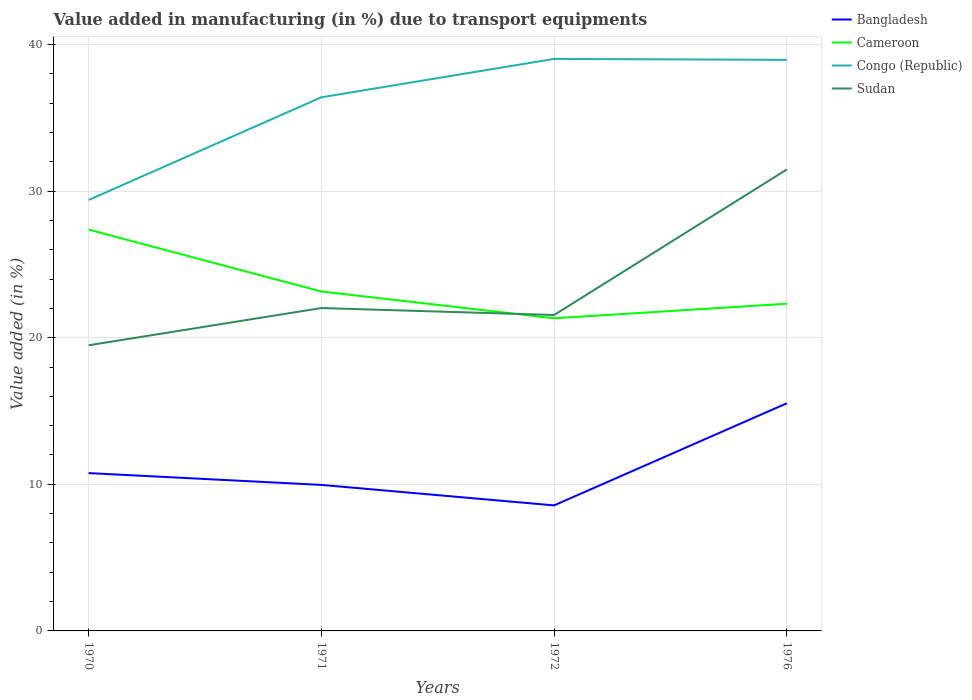How many different coloured lines are there?
Your answer should be compact. 4. Does the line corresponding to Sudan intersect with the line corresponding to Congo (Republic)?
Your answer should be very brief. No. Is the number of lines equal to the number of legend labels?
Offer a terse response. Yes. Across all years, what is the maximum percentage of value added in manufacturing due to transport equipments in Congo (Republic)?
Your answer should be very brief. 29.39. What is the total percentage of value added in manufacturing due to transport equipments in Bangladesh in the graph?
Provide a short and direct response. -6.97. What is the difference between the highest and the second highest percentage of value added in manufacturing due to transport equipments in Sudan?
Your answer should be compact. 11.99. What is the difference between the highest and the lowest percentage of value added in manufacturing due to transport equipments in Sudan?
Make the answer very short. 1. How many lines are there?
Offer a very short reply. 4. Are the values on the major ticks of Y-axis written in scientific E-notation?
Offer a very short reply. No. Does the graph contain grids?
Ensure brevity in your answer.  Yes. How many legend labels are there?
Keep it short and to the point. 4. How are the legend labels stacked?
Provide a succinct answer. Vertical. What is the title of the graph?
Keep it short and to the point. Value added in manufacturing (in %) due to transport equipments. What is the label or title of the X-axis?
Provide a short and direct response. Years. What is the label or title of the Y-axis?
Make the answer very short. Value added (in %). What is the Value added (in %) in Bangladesh in 1970?
Provide a succinct answer. 10.77. What is the Value added (in %) in Cameroon in 1970?
Your response must be concise. 27.37. What is the Value added (in %) in Congo (Republic) in 1970?
Provide a short and direct response. 29.39. What is the Value added (in %) in Sudan in 1970?
Your answer should be very brief. 19.48. What is the Value added (in %) in Bangladesh in 1971?
Provide a short and direct response. 9.96. What is the Value added (in %) in Cameroon in 1971?
Offer a terse response. 23.15. What is the Value added (in %) in Congo (Republic) in 1971?
Offer a very short reply. 36.4. What is the Value added (in %) in Sudan in 1971?
Your answer should be compact. 22.02. What is the Value added (in %) in Bangladesh in 1972?
Your answer should be very brief. 8.56. What is the Value added (in %) in Cameroon in 1972?
Provide a succinct answer. 21.32. What is the Value added (in %) in Congo (Republic) in 1972?
Provide a short and direct response. 39.02. What is the Value added (in %) of Sudan in 1972?
Offer a terse response. 21.55. What is the Value added (in %) in Bangladesh in 1976?
Provide a short and direct response. 15.53. What is the Value added (in %) of Cameroon in 1976?
Your answer should be compact. 22.32. What is the Value added (in %) of Congo (Republic) in 1976?
Ensure brevity in your answer.  38.95. What is the Value added (in %) of Sudan in 1976?
Your answer should be very brief. 31.48. Across all years, what is the maximum Value added (in %) in Bangladesh?
Your answer should be very brief. 15.53. Across all years, what is the maximum Value added (in %) in Cameroon?
Your answer should be compact. 27.37. Across all years, what is the maximum Value added (in %) of Congo (Republic)?
Your answer should be compact. 39.02. Across all years, what is the maximum Value added (in %) of Sudan?
Keep it short and to the point. 31.48. Across all years, what is the minimum Value added (in %) in Bangladesh?
Give a very brief answer. 8.56. Across all years, what is the minimum Value added (in %) of Cameroon?
Your response must be concise. 21.32. Across all years, what is the minimum Value added (in %) in Congo (Republic)?
Offer a very short reply. 29.39. Across all years, what is the minimum Value added (in %) in Sudan?
Your answer should be very brief. 19.48. What is the total Value added (in %) in Bangladesh in the graph?
Ensure brevity in your answer.  44.81. What is the total Value added (in %) in Cameroon in the graph?
Your response must be concise. 94.17. What is the total Value added (in %) in Congo (Republic) in the graph?
Give a very brief answer. 143.76. What is the total Value added (in %) in Sudan in the graph?
Offer a very short reply. 94.53. What is the difference between the Value added (in %) of Bangladesh in 1970 and that in 1971?
Offer a terse response. 0.81. What is the difference between the Value added (in %) in Cameroon in 1970 and that in 1971?
Make the answer very short. 4.22. What is the difference between the Value added (in %) in Congo (Republic) in 1970 and that in 1971?
Provide a succinct answer. -7.01. What is the difference between the Value added (in %) in Sudan in 1970 and that in 1971?
Your answer should be compact. -2.54. What is the difference between the Value added (in %) in Bangladesh in 1970 and that in 1972?
Your answer should be very brief. 2.2. What is the difference between the Value added (in %) of Cameroon in 1970 and that in 1972?
Give a very brief answer. 6.05. What is the difference between the Value added (in %) in Congo (Republic) in 1970 and that in 1972?
Your answer should be compact. -9.62. What is the difference between the Value added (in %) in Sudan in 1970 and that in 1972?
Offer a terse response. -2.07. What is the difference between the Value added (in %) of Bangladesh in 1970 and that in 1976?
Give a very brief answer. -4.76. What is the difference between the Value added (in %) of Cameroon in 1970 and that in 1976?
Offer a very short reply. 5.06. What is the difference between the Value added (in %) of Congo (Republic) in 1970 and that in 1976?
Your answer should be compact. -9.56. What is the difference between the Value added (in %) of Sudan in 1970 and that in 1976?
Offer a terse response. -11.99. What is the difference between the Value added (in %) of Bangladesh in 1971 and that in 1972?
Your response must be concise. 1.4. What is the difference between the Value added (in %) of Cameroon in 1971 and that in 1972?
Your answer should be compact. 1.83. What is the difference between the Value added (in %) of Congo (Republic) in 1971 and that in 1972?
Give a very brief answer. -2.62. What is the difference between the Value added (in %) in Sudan in 1971 and that in 1972?
Keep it short and to the point. 0.47. What is the difference between the Value added (in %) in Bangladesh in 1971 and that in 1976?
Ensure brevity in your answer.  -5.57. What is the difference between the Value added (in %) in Cameroon in 1971 and that in 1976?
Provide a succinct answer. 0.83. What is the difference between the Value added (in %) in Congo (Republic) in 1971 and that in 1976?
Your answer should be compact. -2.55. What is the difference between the Value added (in %) in Sudan in 1971 and that in 1976?
Offer a very short reply. -9.45. What is the difference between the Value added (in %) in Bangladesh in 1972 and that in 1976?
Provide a succinct answer. -6.97. What is the difference between the Value added (in %) in Cameroon in 1972 and that in 1976?
Provide a succinct answer. -0.99. What is the difference between the Value added (in %) in Congo (Republic) in 1972 and that in 1976?
Keep it short and to the point. 0.07. What is the difference between the Value added (in %) in Sudan in 1972 and that in 1976?
Offer a very short reply. -9.93. What is the difference between the Value added (in %) of Bangladesh in 1970 and the Value added (in %) of Cameroon in 1971?
Ensure brevity in your answer.  -12.39. What is the difference between the Value added (in %) in Bangladesh in 1970 and the Value added (in %) in Congo (Republic) in 1971?
Your answer should be compact. -25.63. What is the difference between the Value added (in %) of Bangladesh in 1970 and the Value added (in %) of Sudan in 1971?
Provide a succinct answer. -11.26. What is the difference between the Value added (in %) in Cameroon in 1970 and the Value added (in %) in Congo (Republic) in 1971?
Your response must be concise. -9.02. What is the difference between the Value added (in %) in Cameroon in 1970 and the Value added (in %) in Sudan in 1971?
Your answer should be compact. 5.35. What is the difference between the Value added (in %) of Congo (Republic) in 1970 and the Value added (in %) of Sudan in 1971?
Give a very brief answer. 7.37. What is the difference between the Value added (in %) in Bangladesh in 1970 and the Value added (in %) in Cameroon in 1972?
Ensure brevity in your answer.  -10.56. What is the difference between the Value added (in %) in Bangladesh in 1970 and the Value added (in %) in Congo (Republic) in 1972?
Provide a succinct answer. -28.25. What is the difference between the Value added (in %) in Bangladesh in 1970 and the Value added (in %) in Sudan in 1972?
Keep it short and to the point. -10.78. What is the difference between the Value added (in %) of Cameroon in 1970 and the Value added (in %) of Congo (Republic) in 1972?
Your answer should be very brief. -11.64. What is the difference between the Value added (in %) in Cameroon in 1970 and the Value added (in %) in Sudan in 1972?
Your response must be concise. 5.83. What is the difference between the Value added (in %) of Congo (Republic) in 1970 and the Value added (in %) of Sudan in 1972?
Your answer should be compact. 7.84. What is the difference between the Value added (in %) of Bangladesh in 1970 and the Value added (in %) of Cameroon in 1976?
Your response must be concise. -11.55. What is the difference between the Value added (in %) of Bangladesh in 1970 and the Value added (in %) of Congo (Republic) in 1976?
Your answer should be very brief. -28.19. What is the difference between the Value added (in %) of Bangladesh in 1970 and the Value added (in %) of Sudan in 1976?
Provide a short and direct response. -20.71. What is the difference between the Value added (in %) of Cameroon in 1970 and the Value added (in %) of Congo (Republic) in 1976?
Keep it short and to the point. -11.58. What is the difference between the Value added (in %) in Cameroon in 1970 and the Value added (in %) in Sudan in 1976?
Provide a short and direct response. -4.1. What is the difference between the Value added (in %) of Congo (Republic) in 1970 and the Value added (in %) of Sudan in 1976?
Your response must be concise. -2.08. What is the difference between the Value added (in %) in Bangladesh in 1971 and the Value added (in %) in Cameroon in 1972?
Offer a terse response. -11.37. What is the difference between the Value added (in %) in Bangladesh in 1971 and the Value added (in %) in Congo (Republic) in 1972?
Give a very brief answer. -29.06. What is the difference between the Value added (in %) in Bangladesh in 1971 and the Value added (in %) in Sudan in 1972?
Provide a succinct answer. -11.59. What is the difference between the Value added (in %) of Cameroon in 1971 and the Value added (in %) of Congo (Republic) in 1972?
Offer a very short reply. -15.87. What is the difference between the Value added (in %) in Cameroon in 1971 and the Value added (in %) in Sudan in 1972?
Your response must be concise. 1.6. What is the difference between the Value added (in %) in Congo (Republic) in 1971 and the Value added (in %) in Sudan in 1972?
Provide a short and direct response. 14.85. What is the difference between the Value added (in %) of Bangladesh in 1971 and the Value added (in %) of Cameroon in 1976?
Ensure brevity in your answer.  -12.36. What is the difference between the Value added (in %) in Bangladesh in 1971 and the Value added (in %) in Congo (Republic) in 1976?
Your answer should be compact. -28.99. What is the difference between the Value added (in %) in Bangladesh in 1971 and the Value added (in %) in Sudan in 1976?
Your response must be concise. -21.52. What is the difference between the Value added (in %) of Cameroon in 1971 and the Value added (in %) of Congo (Republic) in 1976?
Keep it short and to the point. -15.8. What is the difference between the Value added (in %) of Cameroon in 1971 and the Value added (in %) of Sudan in 1976?
Your answer should be compact. -8.33. What is the difference between the Value added (in %) in Congo (Republic) in 1971 and the Value added (in %) in Sudan in 1976?
Provide a succinct answer. 4.92. What is the difference between the Value added (in %) in Bangladesh in 1972 and the Value added (in %) in Cameroon in 1976?
Your answer should be very brief. -13.75. What is the difference between the Value added (in %) of Bangladesh in 1972 and the Value added (in %) of Congo (Republic) in 1976?
Ensure brevity in your answer.  -30.39. What is the difference between the Value added (in %) of Bangladesh in 1972 and the Value added (in %) of Sudan in 1976?
Ensure brevity in your answer.  -22.91. What is the difference between the Value added (in %) in Cameroon in 1972 and the Value added (in %) in Congo (Republic) in 1976?
Ensure brevity in your answer.  -17.63. What is the difference between the Value added (in %) of Cameroon in 1972 and the Value added (in %) of Sudan in 1976?
Provide a short and direct response. -10.15. What is the difference between the Value added (in %) of Congo (Republic) in 1972 and the Value added (in %) of Sudan in 1976?
Provide a succinct answer. 7.54. What is the average Value added (in %) of Bangladesh per year?
Your answer should be compact. 11.2. What is the average Value added (in %) in Cameroon per year?
Keep it short and to the point. 23.54. What is the average Value added (in %) of Congo (Republic) per year?
Your answer should be very brief. 35.94. What is the average Value added (in %) in Sudan per year?
Make the answer very short. 23.63. In the year 1970, what is the difference between the Value added (in %) in Bangladesh and Value added (in %) in Cameroon?
Your answer should be compact. -16.61. In the year 1970, what is the difference between the Value added (in %) of Bangladesh and Value added (in %) of Congo (Republic)?
Give a very brief answer. -18.63. In the year 1970, what is the difference between the Value added (in %) in Bangladesh and Value added (in %) in Sudan?
Your answer should be very brief. -8.72. In the year 1970, what is the difference between the Value added (in %) in Cameroon and Value added (in %) in Congo (Republic)?
Your response must be concise. -2.02. In the year 1970, what is the difference between the Value added (in %) in Cameroon and Value added (in %) in Sudan?
Ensure brevity in your answer.  7.89. In the year 1970, what is the difference between the Value added (in %) in Congo (Republic) and Value added (in %) in Sudan?
Your answer should be compact. 9.91. In the year 1971, what is the difference between the Value added (in %) in Bangladesh and Value added (in %) in Cameroon?
Provide a succinct answer. -13.19. In the year 1971, what is the difference between the Value added (in %) in Bangladesh and Value added (in %) in Congo (Republic)?
Your response must be concise. -26.44. In the year 1971, what is the difference between the Value added (in %) of Bangladesh and Value added (in %) of Sudan?
Your response must be concise. -12.06. In the year 1971, what is the difference between the Value added (in %) of Cameroon and Value added (in %) of Congo (Republic)?
Your answer should be very brief. -13.25. In the year 1971, what is the difference between the Value added (in %) in Cameroon and Value added (in %) in Sudan?
Provide a succinct answer. 1.13. In the year 1971, what is the difference between the Value added (in %) of Congo (Republic) and Value added (in %) of Sudan?
Provide a succinct answer. 14.38. In the year 1972, what is the difference between the Value added (in %) in Bangladesh and Value added (in %) in Cameroon?
Give a very brief answer. -12.76. In the year 1972, what is the difference between the Value added (in %) of Bangladesh and Value added (in %) of Congo (Republic)?
Provide a short and direct response. -30.45. In the year 1972, what is the difference between the Value added (in %) in Bangladesh and Value added (in %) in Sudan?
Your answer should be very brief. -12.99. In the year 1972, what is the difference between the Value added (in %) of Cameroon and Value added (in %) of Congo (Republic)?
Provide a succinct answer. -17.69. In the year 1972, what is the difference between the Value added (in %) in Cameroon and Value added (in %) in Sudan?
Provide a short and direct response. -0.22. In the year 1972, what is the difference between the Value added (in %) in Congo (Republic) and Value added (in %) in Sudan?
Offer a terse response. 17.47. In the year 1976, what is the difference between the Value added (in %) of Bangladesh and Value added (in %) of Cameroon?
Your answer should be very brief. -6.79. In the year 1976, what is the difference between the Value added (in %) in Bangladesh and Value added (in %) in Congo (Republic)?
Offer a terse response. -23.42. In the year 1976, what is the difference between the Value added (in %) in Bangladesh and Value added (in %) in Sudan?
Offer a very short reply. -15.95. In the year 1976, what is the difference between the Value added (in %) in Cameroon and Value added (in %) in Congo (Republic)?
Provide a short and direct response. -16.63. In the year 1976, what is the difference between the Value added (in %) in Cameroon and Value added (in %) in Sudan?
Offer a terse response. -9.16. In the year 1976, what is the difference between the Value added (in %) in Congo (Republic) and Value added (in %) in Sudan?
Your answer should be compact. 7.47. What is the ratio of the Value added (in %) in Bangladesh in 1970 to that in 1971?
Offer a terse response. 1.08. What is the ratio of the Value added (in %) of Cameroon in 1970 to that in 1971?
Make the answer very short. 1.18. What is the ratio of the Value added (in %) of Congo (Republic) in 1970 to that in 1971?
Give a very brief answer. 0.81. What is the ratio of the Value added (in %) of Sudan in 1970 to that in 1971?
Keep it short and to the point. 0.88. What is the ratio of the Value added (in %) of Bangladesh in 1970 to that in 1972?
Your response must be concise. 1.26. What is the ratio of the Value added (in %) in Cameroon in 1970 to that in 1972?
Your answer should be very brief. 1.28. What is the ratio of the Value added (in %) in Congo (Republic) in 1970 to that in 1972?
Ensure brevity in your answer.  0.75. What is the ratio of the Value added (in %) of Sudan in 1970 to that in 1972?
Make the answer very short. 0.9. What is the ratio of the Value added (in %) in Bangladesh in 1970 to that in 1976?
Provide a short and direct response. 0.69. What is the ratio of the Value added (in %) of Cameroon in 1970 to that in 1976?
Your answer should be compact. 1.23. What is the ratio of the Value added (in %) of Congo (Republic) in 1970 to that in 1976?
Your answer should be compact. 0.75. What is the ratio of the Value added (in %) of Sudan in 1970 to that in 1976?
Your response must be concise. 0.62. What is the ratio of the Value added (in %) in Bangladesh in 1971 to that in 1972?
Offer a terse response. 1.16. What is the ratio of the Value added (in %) in Cameroon in 1971 to that in 1972?
Provide a succinct answer. 1.09. What is the ratio of the Value added (in %) of Congo (Republic) in 1971 to that in 1972?
Ensure brevity in your answer.  0.93. What is the ratio of the Value added (in %) of Sudan in 1971 to that in 1972?
Provide a short and direct response. 1.02. What is the ratio of the Value added (in %) in Bangladesh in 1971 to that in 1976?
Ensure brevity in your answer.  0.64. What is the ratio of the Value added (in %) of Cameroon in 1971 to that in 1976?
Your answer should be compact. 1.04. What is the ratio of the Value added (in %) in Congo (Republic) in 1971 to that in 1976?
Your answer should be very brief. 0.93. What is the ratio of the Value added (in %) of Sudan in 1971 to that in 1976?
Keep it short and to the point. 0.7. What is the ratio of the Value added (in %) of Bangladesh in 1972 to that in 1976?
Give a very brief answer. 0.55. What is the ratio of the Value added (in %) in Cameroon in 1972 to that in 1976?
Give a very brief answer. 0.96. What is the ratio of the Value added (in %) in Sudan in 1972 to that in 1976?
Offer a very short reply. 0.68. What is the difference between the highest and the second highest Value added (in %) in Bangladesh?
Keep it short and to the point. 4.76. What is the difference between the highest and the second highest Value added (in %) of Cameroon?
Ensure brevity in your answer.  4.22. What is the difference between the highest and the second highest Value added (in %) in Congo (Republic)?
Give a very brief answer. 0.07. What is the difference between the highest and the second highest Value added (in %) in Sudan?
Provide a succinct answer. 9.45. What is the difference between the highest and the lowest Value added (in %) of Bangladesh?
Provide a short and direct response. 6.97. What is the difference between the highest and the lowest Value added (in %) of Cameroon?
Provide a succinct answer. 6.05. What is the difference between the highest and the lowest Value added (in %) of Congo (Republic)?
Offer a very short reply. 9.62. What is the difference between the highest and the lowest Value added (in %) in Sudan?
Your response must be concise. 11.99. 